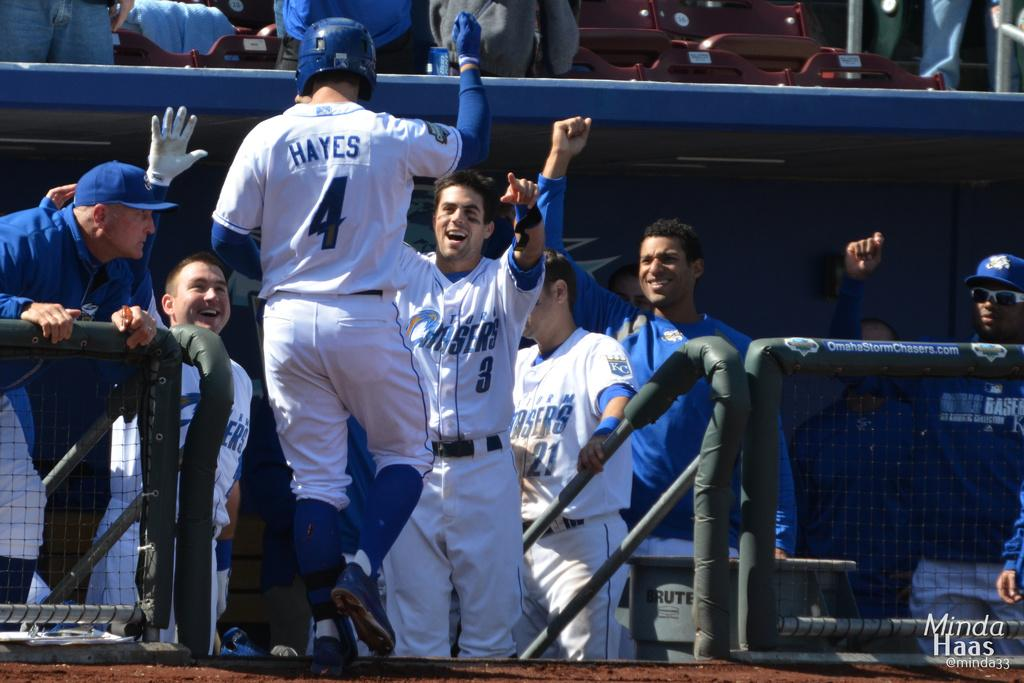<image>
Summarize the visual content of the image. baseball players are celebrating in white and blue uniforms that say Chasers on them. 